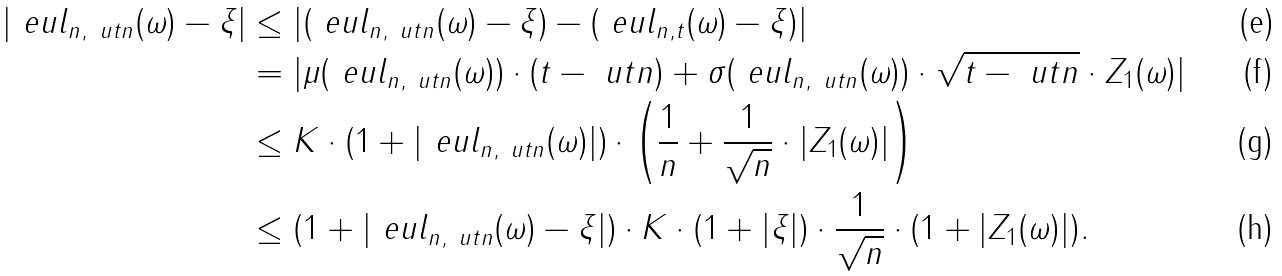<formula> <loc_0><loc_0><loc_500><loc_500>| \ e u l _ { n , \ u t n } ( \omega ) - \xi | & \leq | ( \ e u l _ { n , \ u t n } ( \omega ) - \xi ) - ( \ e u l _ { n , t } ( \omega ) - \xi ) | \\ & = | \mu ( \ e u l _ { n , \ u t n } ( \omega ) ) \cdot ( t - \ u t n ) + \sigma ( \ e u l _ { n , \ u t n } ( \omega ) ) \cdot \sqrt { t - \ u t n } \cdot Z _ { 1 } ( \omega ) | \\ & \leq K \cdot ( 1 + | \ e u l _ { n , \ u t n } ( \omega ) | ) \cdot \left ( \frac { 1 } { n } + \frac { 1 } { \sqrt { n } } \cdot | Z _ { 1 } ( \omega ) | \right ) \\ & \leq ( 1 + | \ e u l _ { n , \ u t n } ( \omega ) - \xi | ) \cdot K \cdot ( 1 + | \xi | ) \cdot \frac { 1 } { \sqrt { n } } \cdot ( 1 + | Z _ { 1 } ( \omega ) | ) .</formula> 